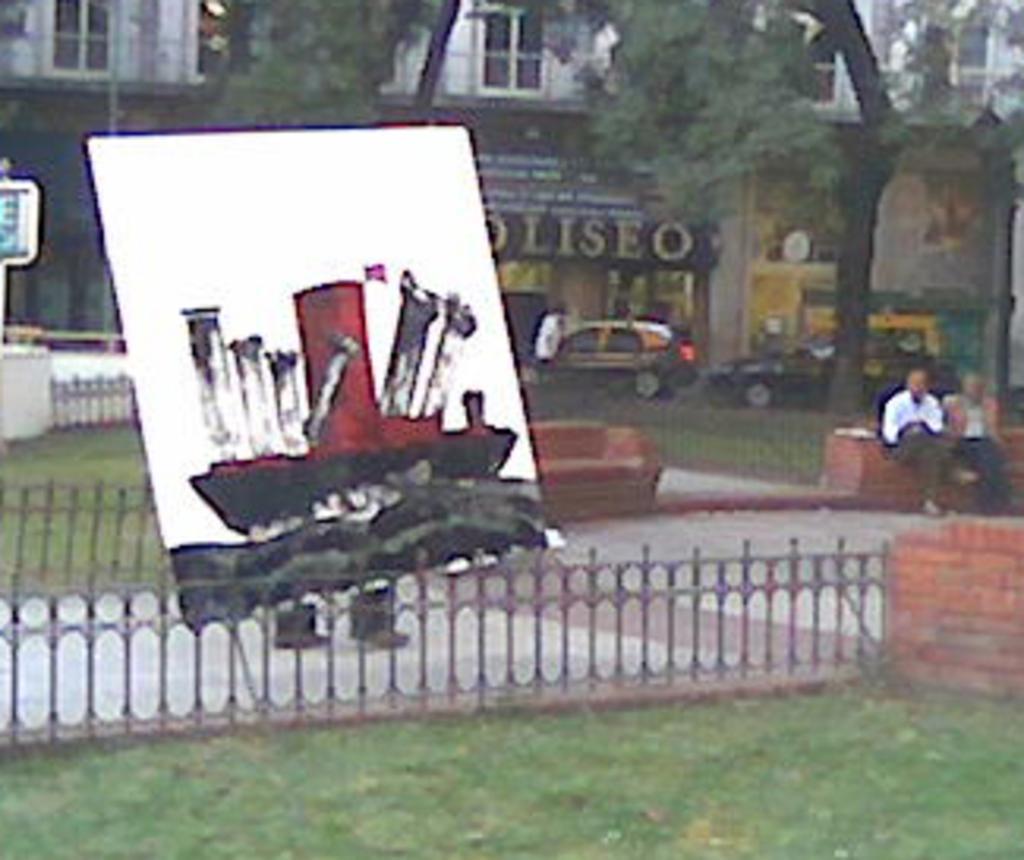Can you describe this image briefly? In this image, we can see grass on the ground, at some area, there is a fence, we can see the poster, there are two persons sitting on the wall, we can see some trees, there are some cars, we can see the building. 